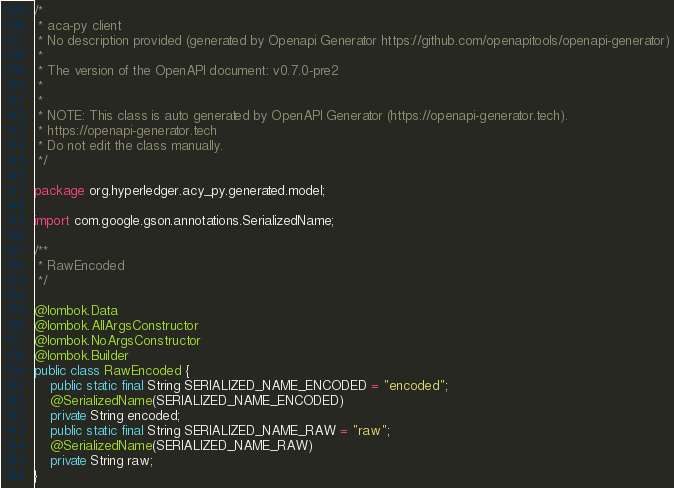Convert code to text. <code><loc_0><loc_0><loc_500><loc_500><_Java_>/*
 * aca-py client
 * No description provided (generated by Openapi Generator https://github.com/openapitools/openapi-generator)
 *
 * The version of the OpenAPI document: v0.7.0-pre2
 * 
 *
 * NOTE: This class is auto generated by OpenAPI Generator (https://openapi-generator.tech).
 * https://openapi-generator.tech
 * Do not edit the class manually.
 */

package org.hyperledger.acy_py.generated.model;

import com.google.gson.annotations.SerializedName;

/**
 * RawEncoded
 */

@lombok.Data
@lombok.AllArgsConstructor
@lombok.NoArgsConstructor
@lombok.Builder
public class RawEncoded {
    public static final String SERIALIZED_NAME_ENCODED = "encoded";
    @SerializedName(SERIALIZED_NAME_ENCODED)
    private String encoded;
    public static final String SERIALIZED_NAME_RAW = "raw";
    @SerializedName(SERIALIZED_NAME_RAW)
    private String raw;
}
</code> 